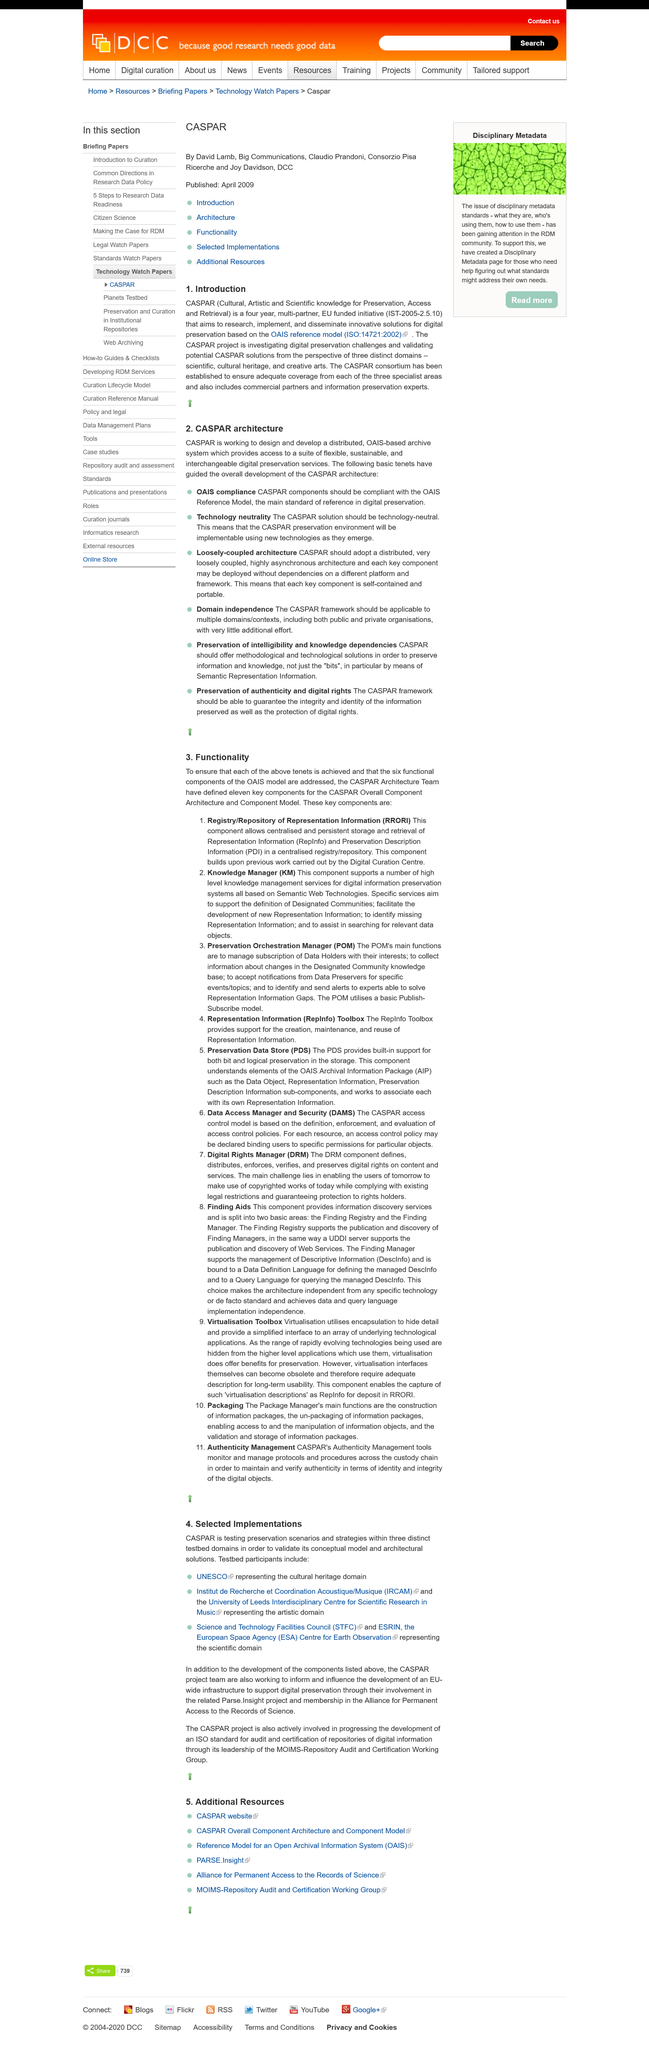Identify some key points in this picture. The OASIS reference model was published in 2002, according to the "Introduction" section of the document. The CASPAR initiative is investigating the domains of scientific, cultural heritage, and creative arts in order to advance its research goals. The CASPAR initiative is funded by the European Union. 